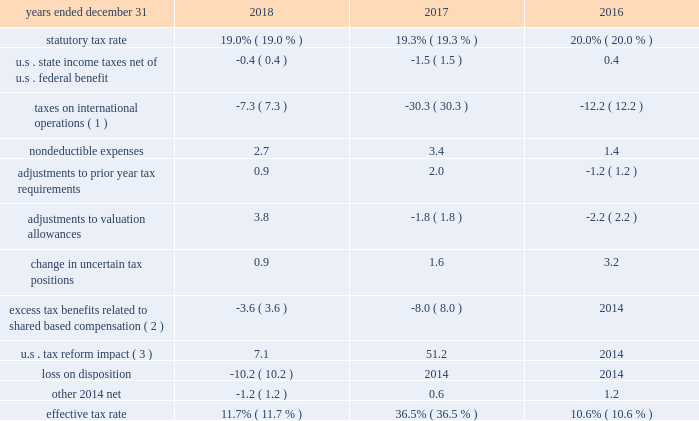
( 1 ) the company determines the adjustment for taxes on international operations based on the difference between the statutory tax rate applicable to earnings in each foreign jurisdiction and the enacted rate of 19.0% ( 19.0 % ) , 19.3% ( 19.3 % ) and 20.0% ( 20.0 % ) at december 31 , 2018 , 2017 , and 2016 , respectively .
The benefit to the company 2019s effective income tax rate from taxes on international operations relates to benefits from lower-taxed global operations , primarily due to the use of global funding structures and the tax holiday in singapore .
The impact decreased from 2017 to 2018 primarily as a result of the decrease in the u.s .
Federal tax ( 2 ) with the adoption of asu 2016-09 in 2017 , excess tax benefits and deficiencies from share-based payment transactions are recognized as income tax expense or benefit in the company 2019s consolidated statements of income .
( 3 ) the impact of the tax reform act including the transition tax , the re-measurement of u.s .
Deferred tax assets and liabilities from 35% ( 35 % ) to 21% ( 21 % ) , withholding tax accruals , and the allocation of tax benefit between continuing operations and discontinued operations related to utilization of foreign tax credits. .
What is the difference between the statutory tax rate and the effective tax rate for international operations in 2018? 
Computations: (11.7% - 19.0%)
Answer: -0.073. 